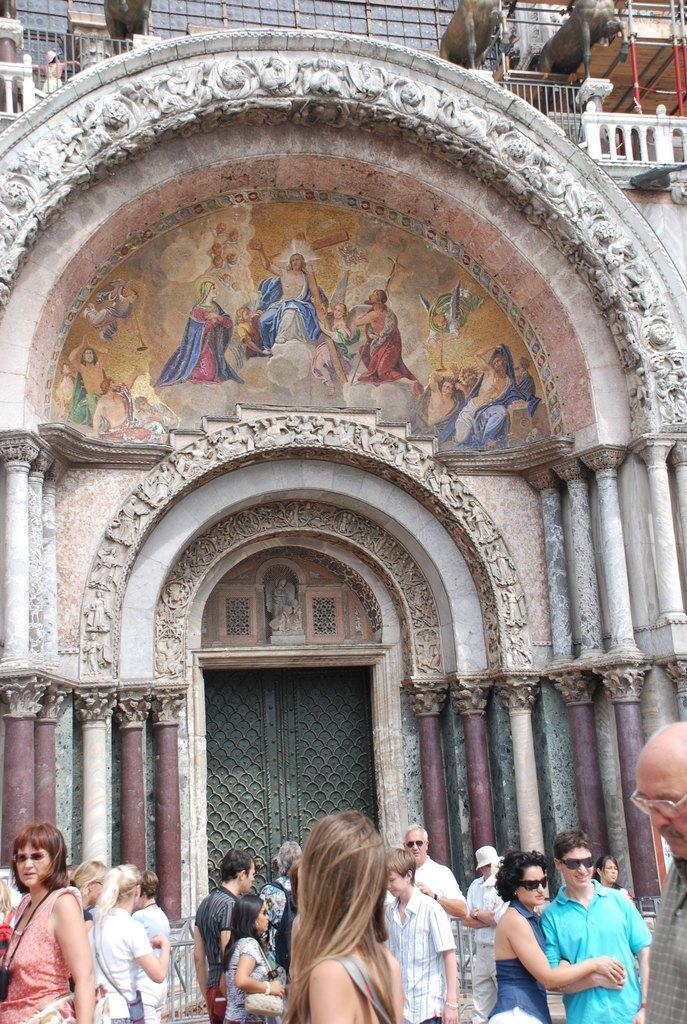Please provide a concise description of this image. In this picture we can see a group of people, pillars, doors, statues, painting on the wall and some objects. 